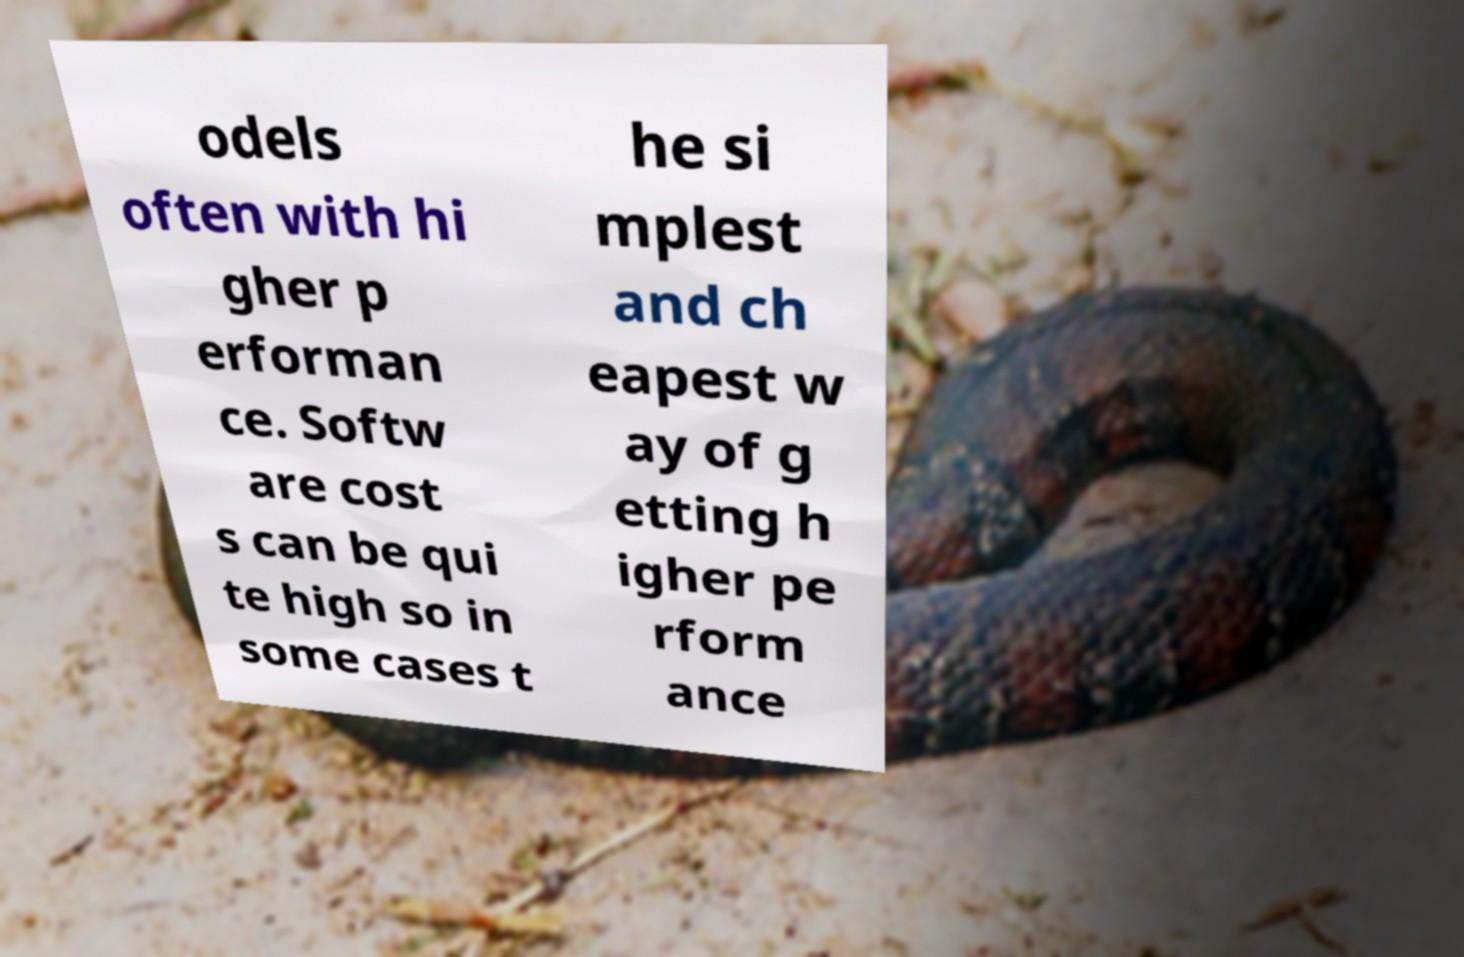Please read and relay the text visible in this image. What does it say? odels often with hi gher p erforman ce. Softw are cost s can be qui te high so in some cases t he si mplest and ch eapest w ay of g etting h igher pe rform ance 